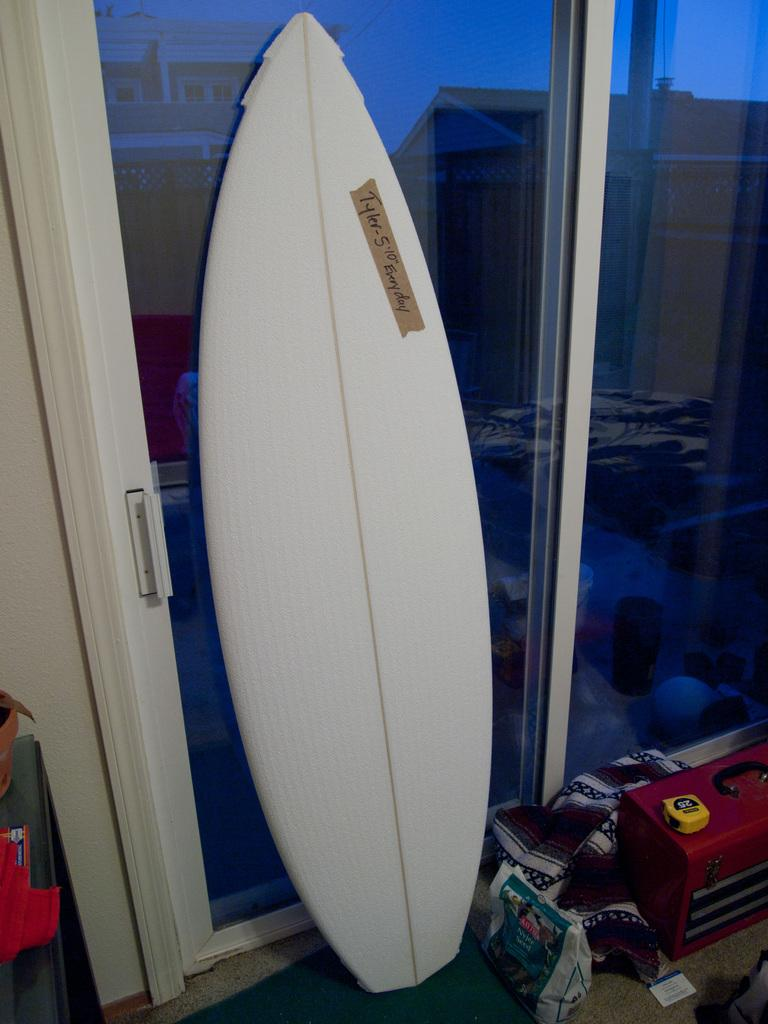What is the main object in the center of the image? There is a surfing board in the center of the image. What can be seen on the right side of the image? There is a briefcase and clothes on the right side of the image, as well as a cover placed on the floor. What is visible in the background of the image? There is a door and a wall visible in the background of the image. How many crayons are being used to draw on the surfing board in the image? There are no crayons or drawing activity visible on the surfing board in the image. Is there a rainstorm occurring outside the door in the background of the image? There is no indication of a rainstorm or any weather conditions in the image. 